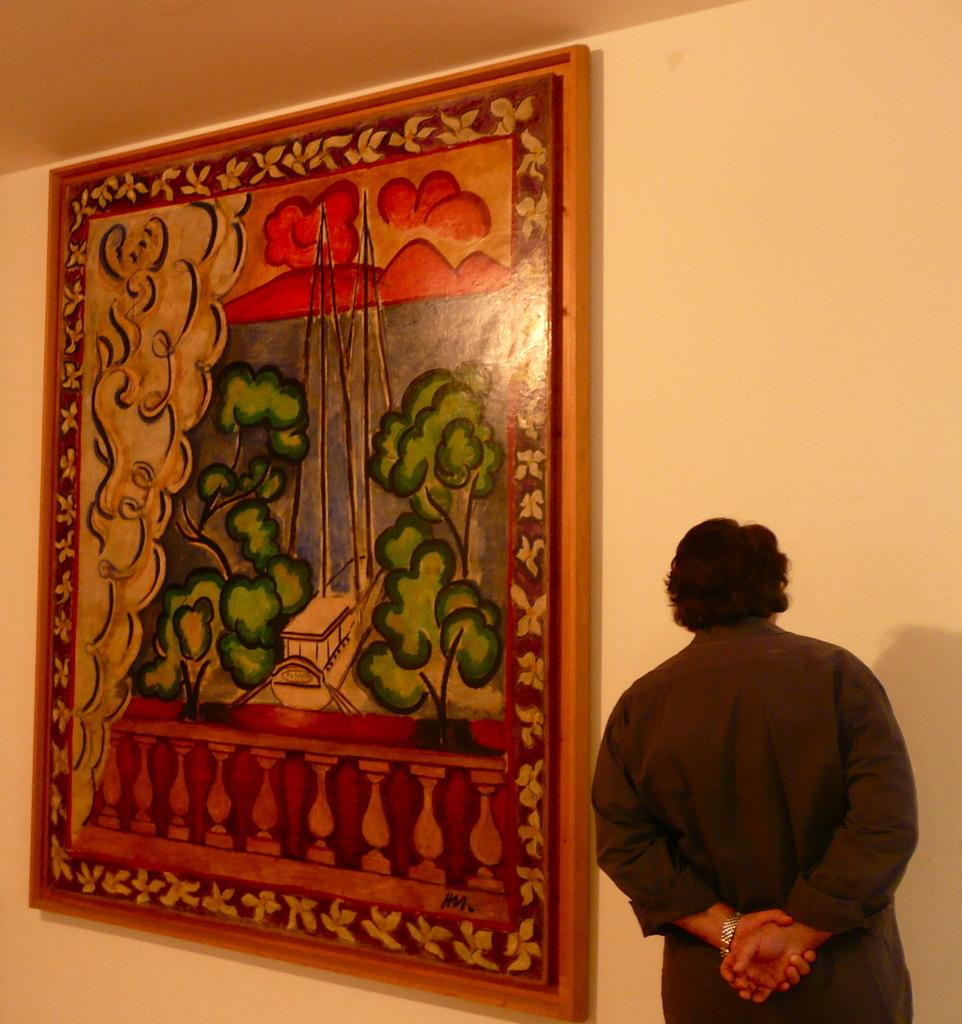What is the main subject in the foreground of the picture? There is a man in the foreground of the picture. What is the man wearing? The man is wearing a brown shirt and brown pants. Where is the man standing in relation to the wall? The man is standing near a wall. What can be seen attached to the wall? There is a painted frame attached to the wall. Can you tell me how many cacti are growing near the man in the image? There are no cacti present in the image; the focus is on the man and the wall with the painted frame. What type of root can be seen supporting the man in the image? The man is standing on his own two feet, and there are no visible roots in the image. 